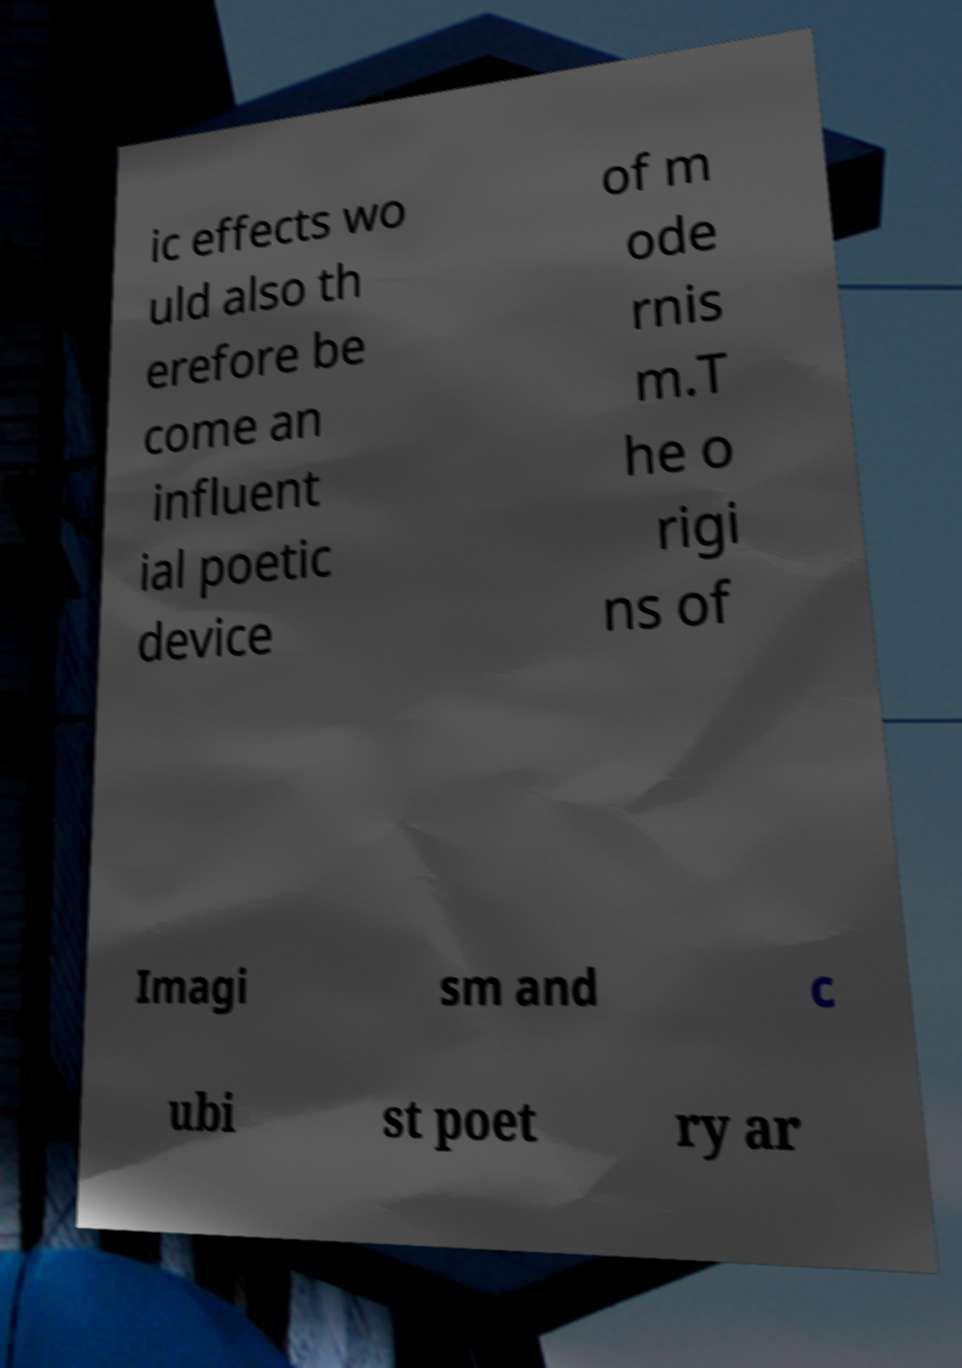Please identify and transcribe the text found in this image. ic effects wo uld also th erefore be come an influent ial poetic device of m ode rnis m.T he o rigi ns of Imagi sm and c ubi st poet ry ar 